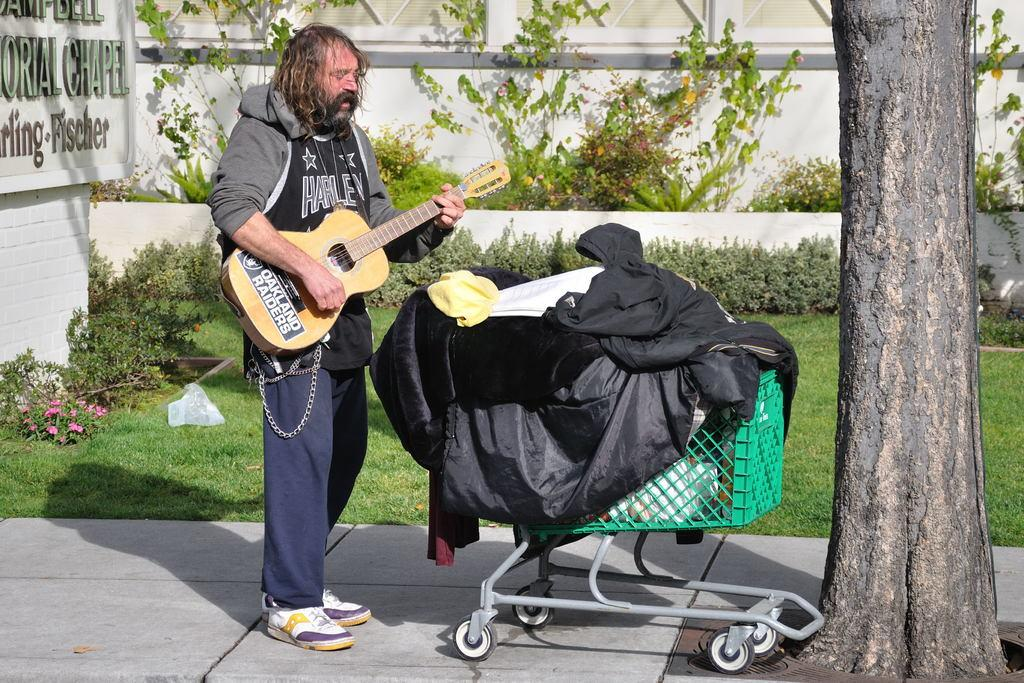What is the person holding in the image? The person is holding a guitar. What is in front of the person? There is a cart in front of the person. What is on the cart? The cart contains clothes and other items. What type of natural environment is visible in the image? There are plants and grass in the image. What is attached to the wall in the image? A board is attached to a wall. What type of approval is the person seeking in the image? There is no indication in the image that the person is seeking any approval. 